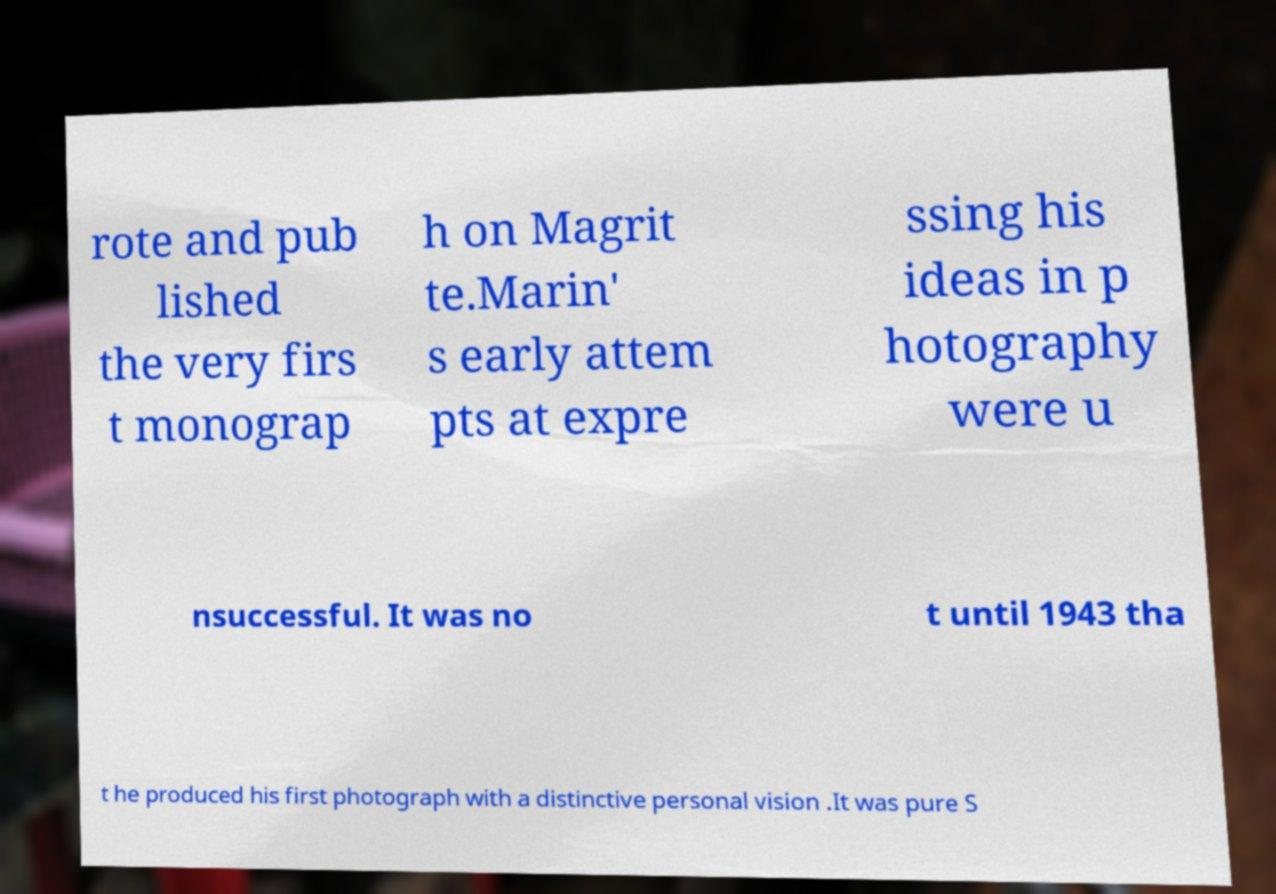Please read and relay the text visible in this image. What does it say? rote and pub lished the very firs t monograp h on Magrit te.Marin' s early attem pts at expre ssing his ideas in p hotography were u nsuccessful. It was no t until 1943 tha t he produced his first photograph with a distinctive personal vision .It was pure S 